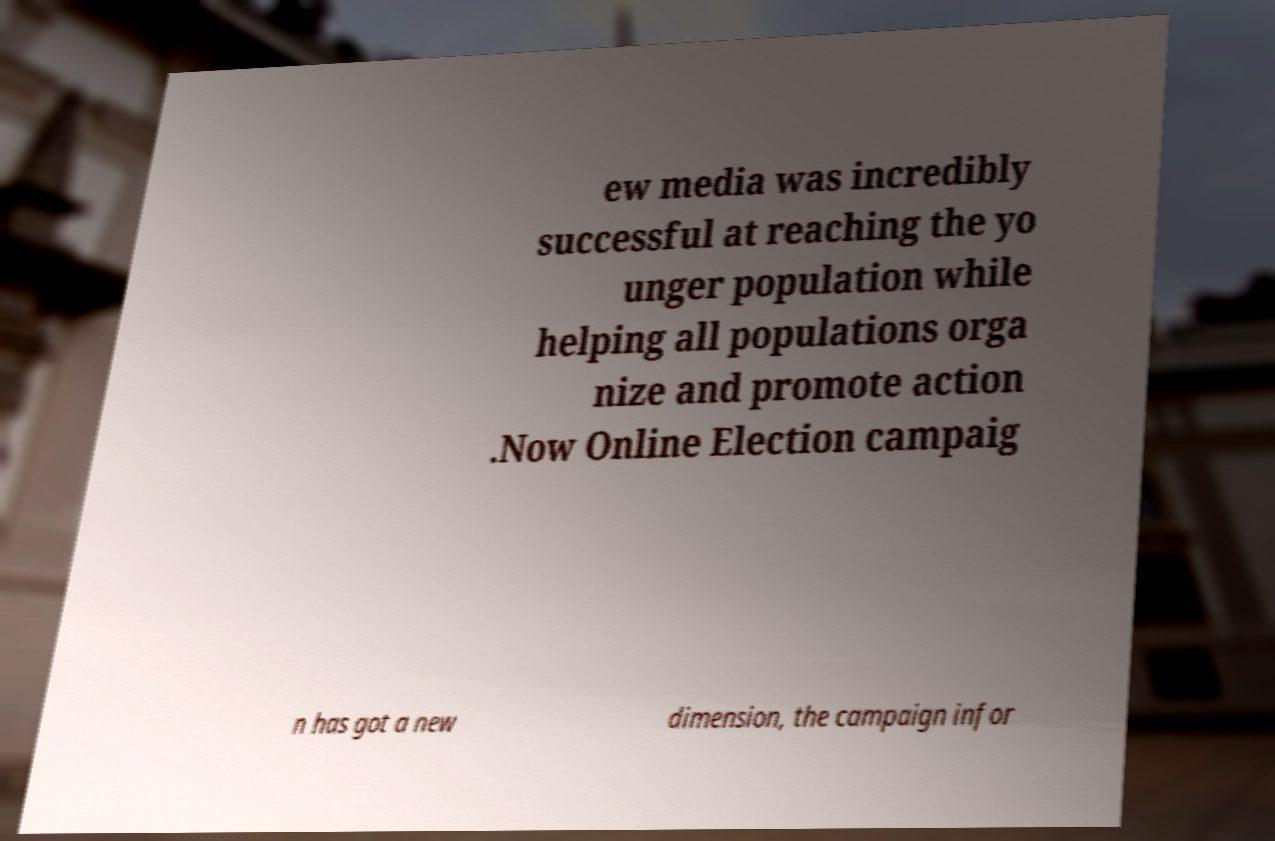Please identify and transcribe the text found in this image. ew media was incredibly successful at reaching the yo unger population while helping all populations orga nize and promote action .Now Online Election campaig n has got a new dimension, the campaign infor 